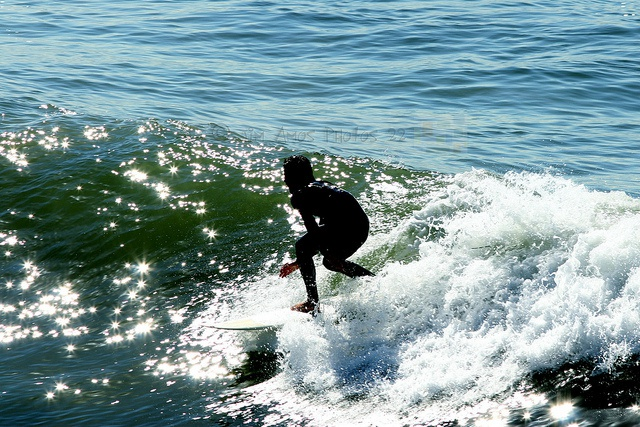Describe the objects in this image and their specific colors. I can see people in lightblue, black, gray, white, and darkgray tones and surfboard in lightblue, white, darkgray, gray, and black tones in this image. 